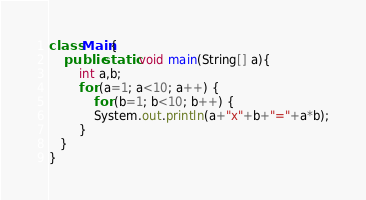<code> <loc_0><loc_0><loc_500><loc_500><_Java_>class Main{
    public static void main(String[] a){
    	int a,b;
    	for (a=1; a<10; a++) {
    		for (b=1; b<10; b++) {
     		System.out.println(a+"x"+b+"="+a*b);
    	}
   }
}</code> 